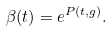Convert formula to latex. <formula><loc_0><loc_0><loc_500><loc_500>\beta ( t ) = e ^ { P ( t , g ) } .</formula> 